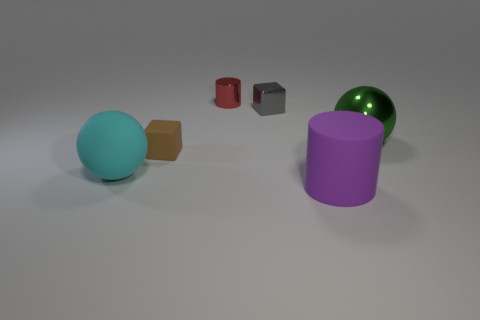Add 4 matte balls. How many objects exist? 10 Subtract all balls. How many objects are left? 4 Add 1 big matte spheres. How many big matte spheres are left? 2 Add 1 tiny brown matte cubes. How many tiny brown matte cubes exist? 2 Subtract 1 brown blocks. How many objects are left? 5 Subtract all small red metal things. Subtract all gray cubes. How many objects are left? 4 